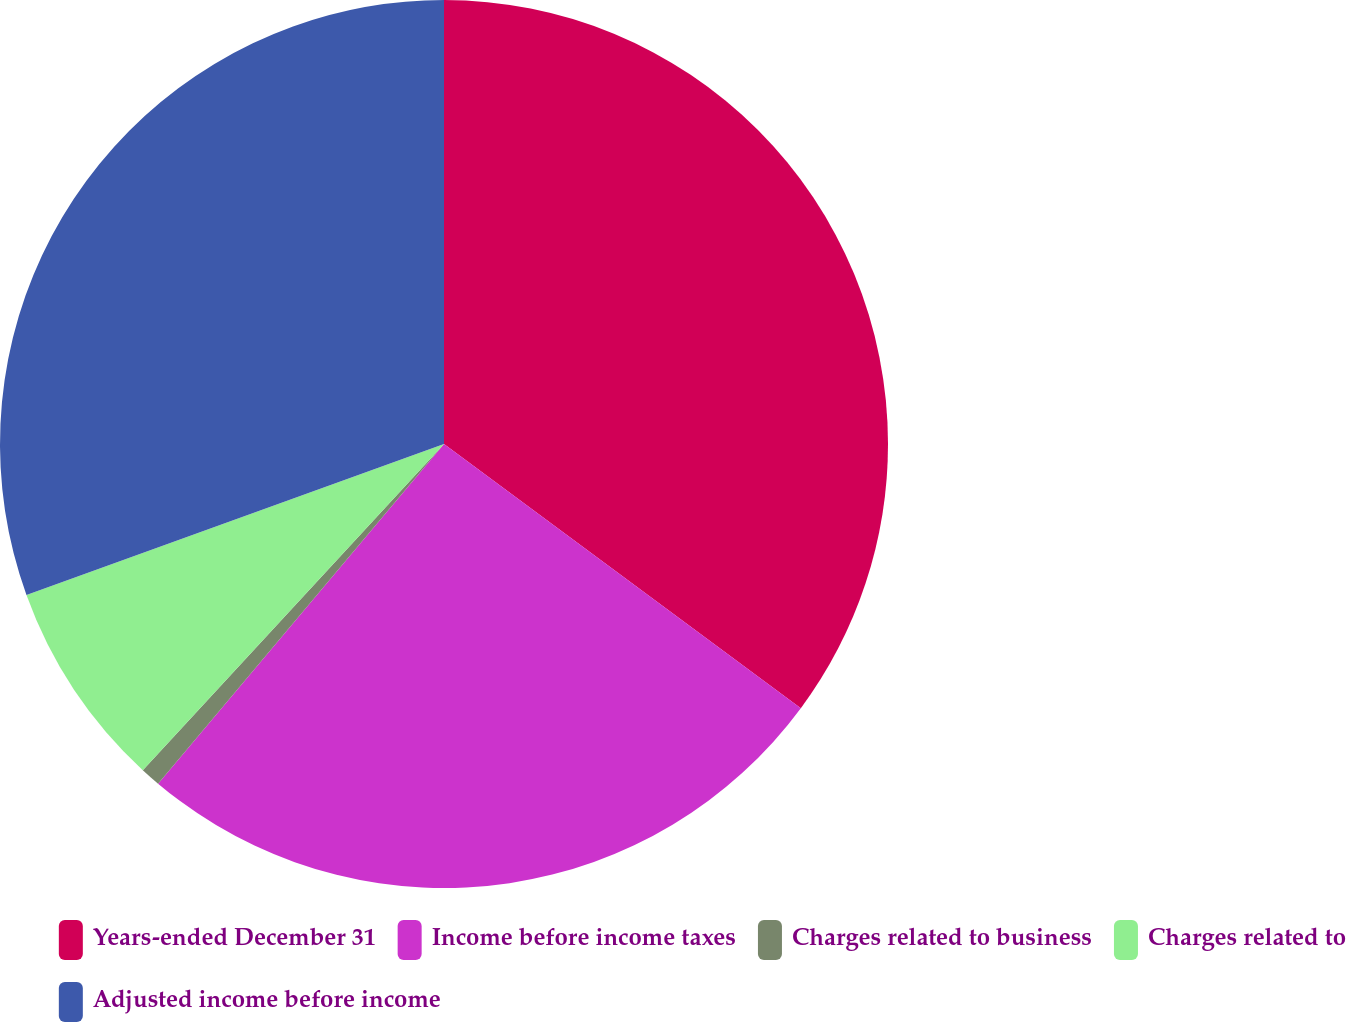<chart> <loc_0><loc_0><loc_500><loc_500><pie_chart><fcel>Years-ended December 31<fcel>Income before income taxes<fcel>Charges related to business<fcel>Charges related to<fcel>Adjusted income before income<nl><fcel>35.14%<fcel>25.99%<fcel>0.73%<fcel>7.61%<fcel>30.52%<nl></chart> 